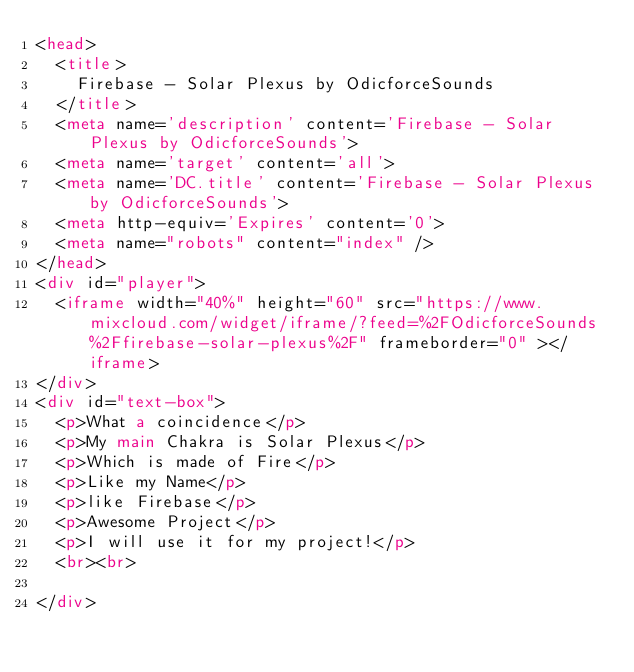<code> <loc_0><loc_0><loc_500><loc_500><_HTML_><head>
  <title>
    Firebase - Solar Plexus by OdicforceSounds
  </title>
  <meta name='description' content='Firebase - Solar Plexus by OdicforceSounds'>
  <meta name='target' content='all'>
  <meta name='DC.title' content='Firebase - Solar Plexus by OdicforceSounds'>
  <meta http-equiv='Expires' content='0'>
  <meta name="robots" content="index" />
</head>
<div id="player">
  <iframe width="40%" height="60" src="https://www.mixcloud.com/widget/iframe/?feed=%2FOdicforceSounds%2Ffirebase-solar-plexus%2F" frameborder="0" ></iframe>
</div>
<div id="text-box">
  <p>What a coincidence</p>
  <p>My main Chakra is Solar Plexus</p>
  <p>Which is made of Fire</p>
  <p>Like my Name</p>
  <p>like Firebase</p>
  <p>Awesome Project</p>
  <p>I will use it for my project!</p>
  <br><br>
  
</div></code> 